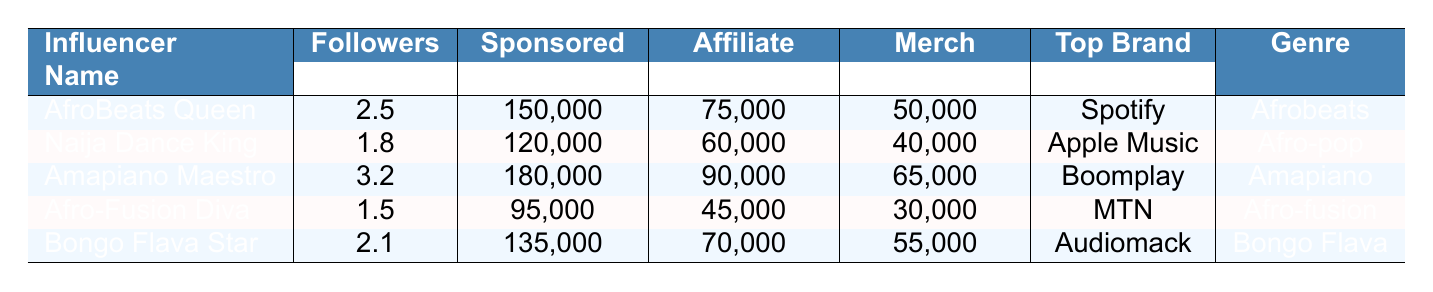What is the sponsored post revenue for Amapiano Maestro? According to the table, the sponsored post revenue for Amapiano Maestro is explicitly listed under the "Sponsored Revenue" column for this influencer. The value is 180,000.
Answer: 180,000 Which influencer has the highest merchandise sales revenue? To find the highest merchandise sales revenue, I will compare the values in the "Merch Revenue" column. Amapiano Maestro has 65,000, which is the highest among the listed influencers.
Answer: Amapiano Maestro What is the total revenue from sponsored posts for all influencers combined? I will sum up the values in the "Sponsored Revenue" column: 150,000 + 120,000 + 180,000 + 95,000 + 135,000 = 680,000.
Answer: 680,000 Which influencer corresponds to the top brand collaboration "MTN"? According to the table, "MTN" is listed as the top brand for Afro-Fusion Diva under the "Top Brand" column.
Answer: Afro-Fusion Diva What is the average affiliate marketing revenue across all influencers? The affiliate marketing revenues are 75,000, 60,000, 90,000, 45,000, and 70,000. Summing these gives 330,000, and dividing by 5 (the number of influencers) yields an average of 66,000.
Answer: 66,000 Is the engagement rate of Naija Dance King higher than that of Afro-Fusion Diva? The engagement rate for Naija Dance King is 0.04, while for Afro-Fusion Diva, it is 0.03. Therefore, Naija Dance King has a higher engagement rate.
Answer: Yes What is the difference in sponsored post revenue between AfroBeats Queen and Bongo Flava Star? The sponsored post revenue for AfroBeats Queen is 150,000 and for Bongo Flava Star is 135,000. The difference is 150,000 - 135,000 = 15,000.
Answer: 15,000 Which genre is associated with the influencer that has the most followers? The influencer with the most followers is Amapiano Maestro, who has 3,200,000 followers. The genre associated with this influencer, according to the "Genre" column, is Amapiano.
Answer: Amapiano What is the total revenue generated by Amapiano Maestro from all sources? To find the total revenue for Amapiano Maestro, I add the sponsored post revenue (180,000), affiliate marketing revenue (90,000), and merchandise sales revenue (65,000): 180,000 + 90,000 + 65,000 = 335,000.
Answer: 335,000 Which influencer has the lowest average views per post? Looking at the "Average Views" column, Afro-Fusion Diva has the lowest average views per post at 280,000.
Answer: Afro-Fusion Diva What is the engagement rate of the influencer with the top merchandise item "Dance Tutorial DVDs"? The top merchandise item "Dance Tutorial DVDs" belongs to Naija Dance King; its engagement rate is found in the "Engagement Rate" column, which is 0.04.
Answer: 0.04 